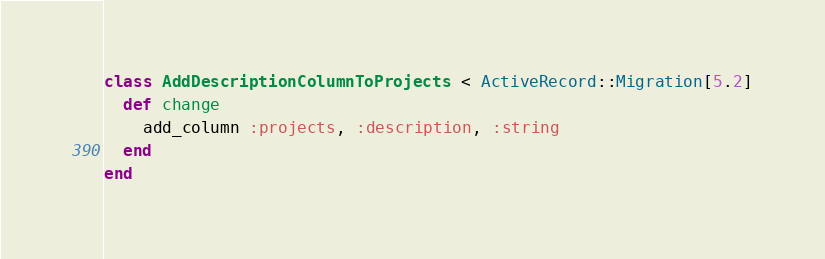<code> <loc_0><loc_0><loc_500><loc_500><_Ruby_>class AddDescriptionColumnToProjects < ActiveRecord::Migration[5.2]
  def change
    add_column :projects, :description, :string
  end
end
</code> 